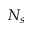Convert formula to latex. <formula><loc_0><loc_0><loc_500><loc_500>N _ { s }</formula> 